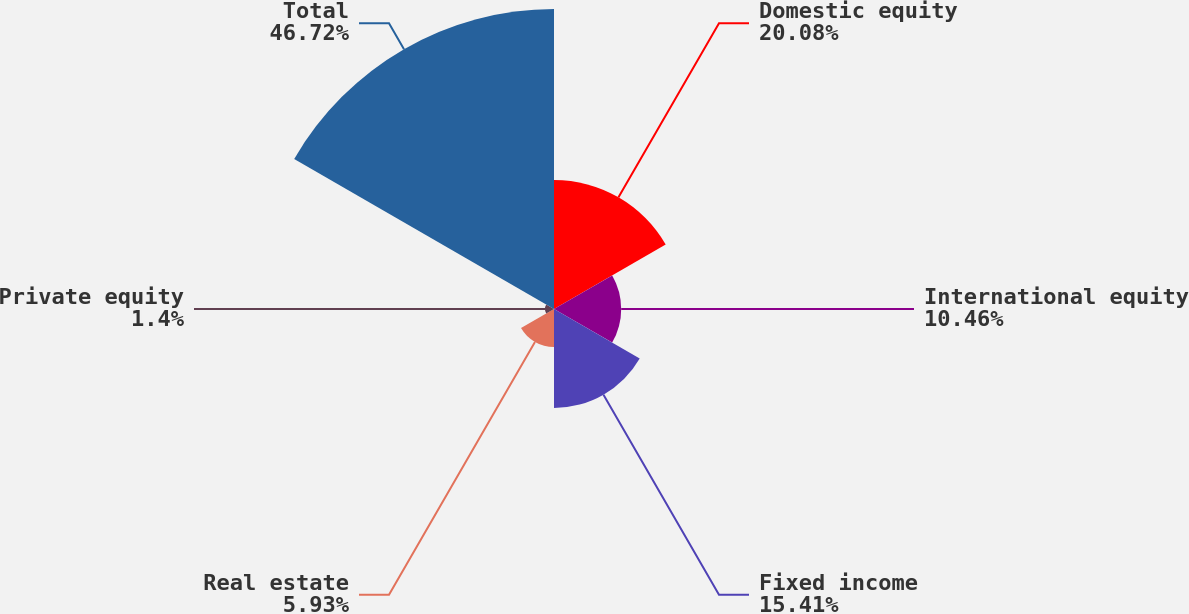Convert chart. <chart><loc_0><loc_0><loc_500><loc_500><pie_chart><fcel>Domestic equity<fcel>International equity<fcel>Fixed income<fcel>Real estate<fcel>Private equity<fcel>Total<nl><fcel>20.08%<fcel>10.46%<fcel>15.41%<fcel>5.93%<fcel>1.4%<fcel>46.71%<nl></chart> 